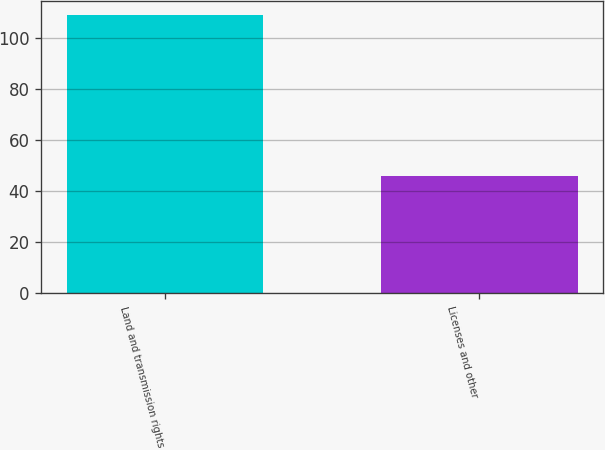Convert chart to OTSL. <chart><loc_0><loc_0><loc_500><loc_500><bar_chart><fcel>Land and transmission rights<fcel>Licenses and other<nl><fcel>109<fcel>46<nl></chart> 